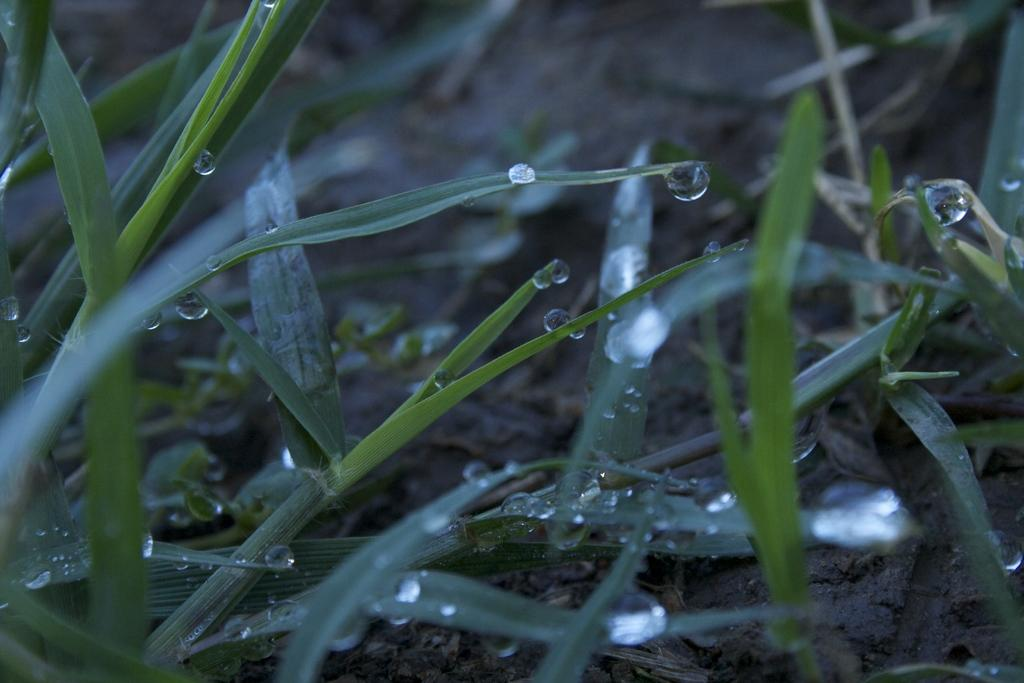What type of living organisms can be seen in the image? Plants can be seen in the image. What else is visible in the image besides the plants? There are water drops visible in the image. Reasoning: Let' Let's think step by step in order to produce the conversation. We start by identifying the main subject in the image, which is the plants. Then, we expand the conversation to include other items that are also visible, such as water drops. Each question is designed to elicit a specific detail about the image that is known from the provided facts. Absurd Question/Answer: What type of field is visible in the image? There is no field present in the image; it only contains plants and water drops. What advice can be given to the plants in the image? There is no need to give advice to the plants in the image, as they are not living beings capable of understanding or following advice. 